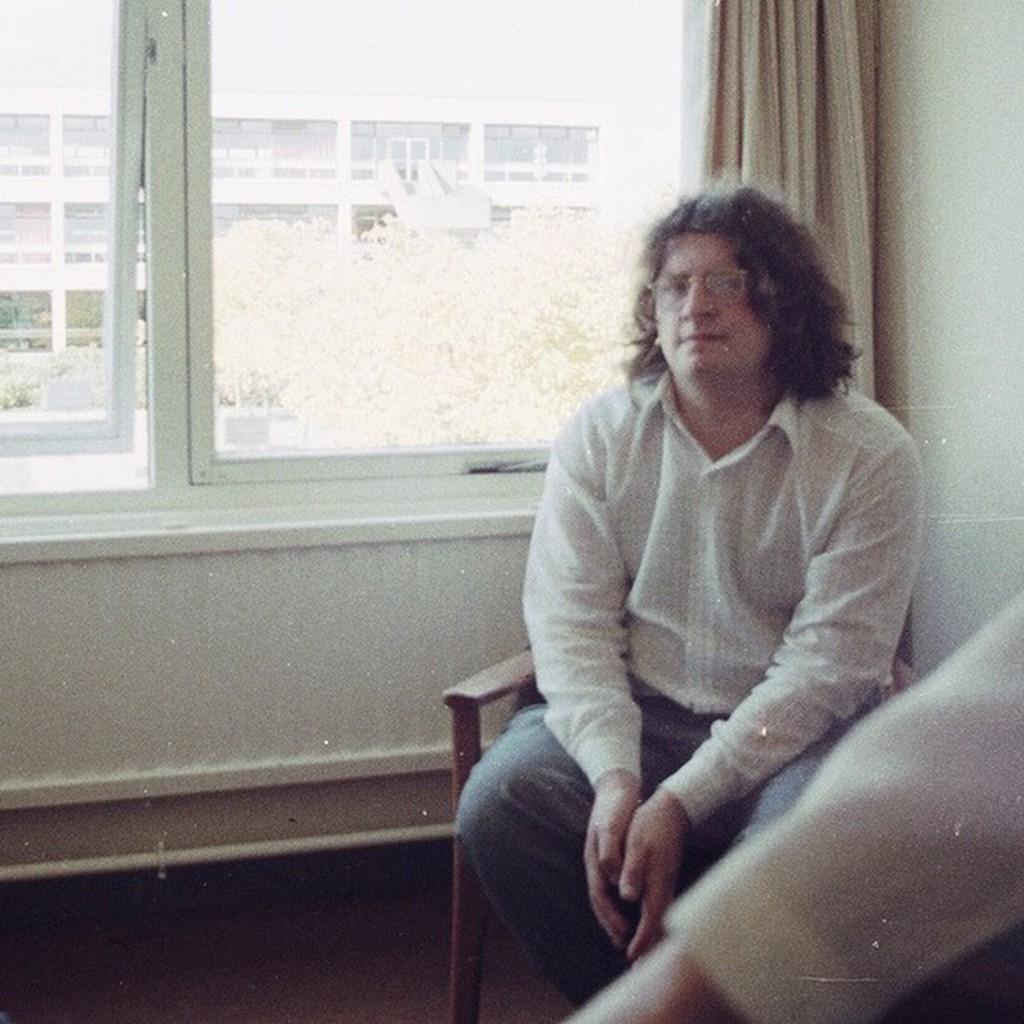In one or two sentences, can you explain what this image depicts? In this picture we can see a person sitting on a chair and in the background we can see a wall, windows, curtain, trees, building. 